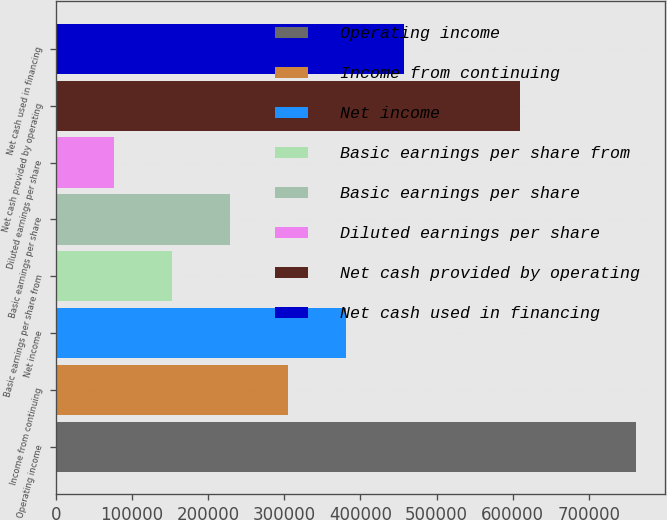<chart> <loc_0><loc_0><loc_500><loc_500><bar_chart><fcel>Operating income<fcel>Income from continuing<fcel>Net income<fcel>Basic earnings per share from<fcel>Basic earnings per share<fcel>Diluted earnings per share<fcel>Net cash provided by operating<fcel>Net cash used in financing<nl><fcel>761752<fcel>304702<fcel>380877<fcel>152353<fcel>228528<fcel>76177.8<fcel>609402<fcel>457052<nl></chart> 